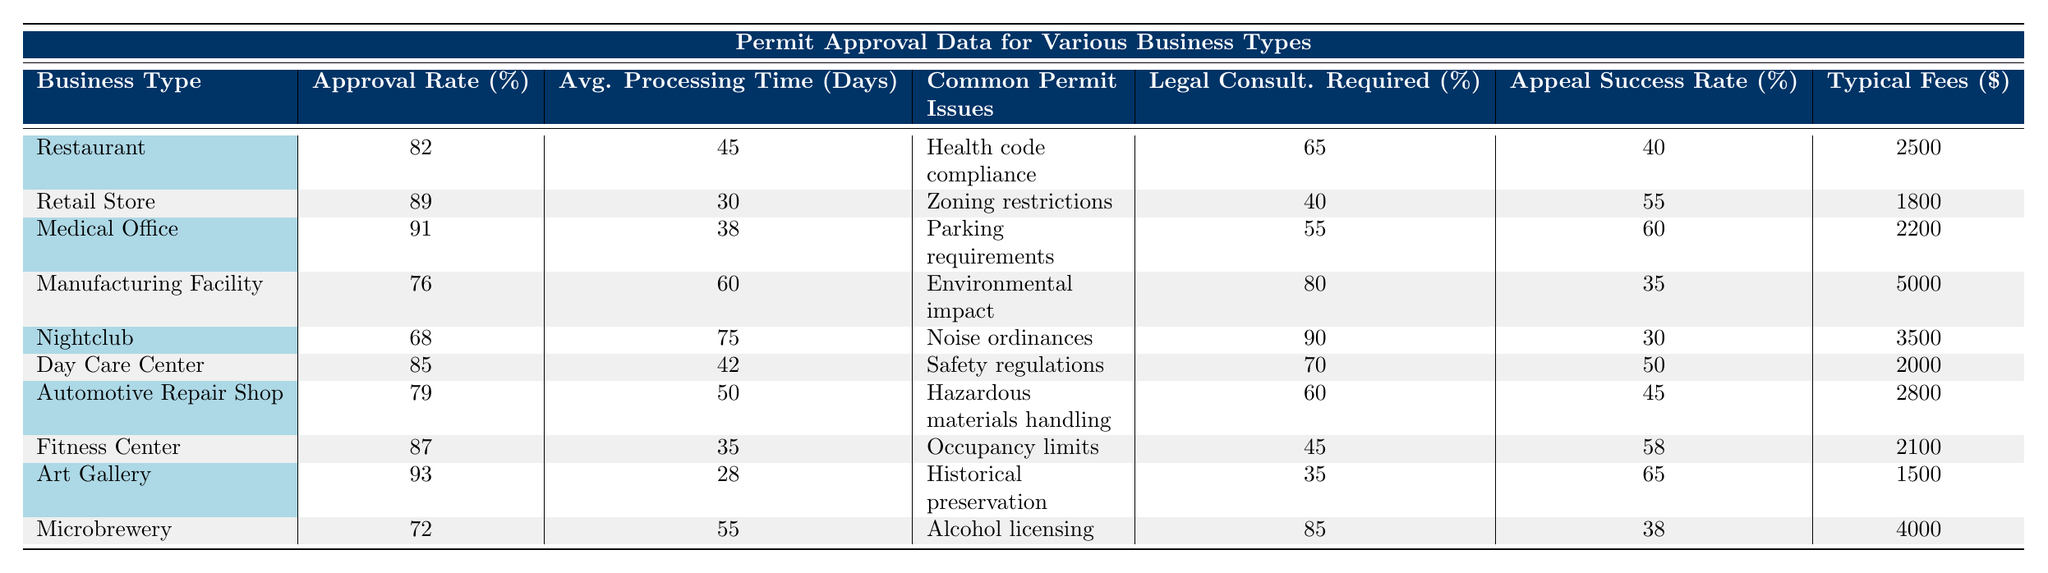What is the permit approval rate for Fitness Centers? According to the table, the approval rate for Fitness Centers is listed in the "Permit Approval Rate (%)" column next to "Fitness Center," which shows 87%.
Answer: 87% Which business type has the highest permit approval rate? In the table, the "Permit Approval Rate (%)" for each business type is listed. The highest rate is found next to "Art Gallery," which has an approval rate of 93%.
Answer: Art Gallery What is the average processing time for Medical Offices? The average processing time for Medical Offices is found in the "Average Processing Time (Days)" column corresponding to "Medical Office," which shows 38 days.
Answer: 38 days How many business types require legal consultations 70% of the time or more? The table can be analyzed by looking at the "Legal Consultations Required (%)" column. Counting the values that are 70% or higher, we find that Nightclubs (90%), Manufacturing Facilities (80%), and Microbreweries (85%) meet this criterion, totaling 4 business types.
Answer: 4 What is the rejection appeal success rate for Day Care Centers? Looking at the "Rejection Appeal Success Rate (%)" column next to "Day Care Center," we see it is recorded as 50%.
Answer: 50% Which business type has the longest average permit processing time, and how many days is it? By reviewing the "Average Processing Time (Days)" column, the longest processing time is associated with Nightclubs at 75 days. This is the maximum value found in that column.
Answer: Nightclub, 75 days Is the typical permit fee for Automotive Repair Shops greater than $2,500? The "Typical Permit Fees ($)" shows $2,800 for Automotive Repair Shops, which is indeed greater than $2,500.
Answer: Yes Calculate the average permit approval rate for all business types. To find the average approval rate, we sum the rates (82 + 89 + 91 + 76 + 68 + 85 + 79 + 87 + 93 + 72 = 922) and divide by the total number of business types (10). The average approval rate is 922/10 = 92.2%.
Answer: 92.2% What is the most common permit issue faced by Restaurants? The relevant column, "Common Permit Issues," lists "Health code compliance" next to Restaurants, indicating that this is their main issue.
Answer: Health code compliance Are Nightclubs and Manufacturing Facilities equally likely to have their permits approved based on the rates provided? The table shows that Manufacturing Facilities have an approval rate of 76%, while Nightclubs have an approval rate of 68%. Since 76% is higher, they are not equally likely to be approved.
Answer: No 